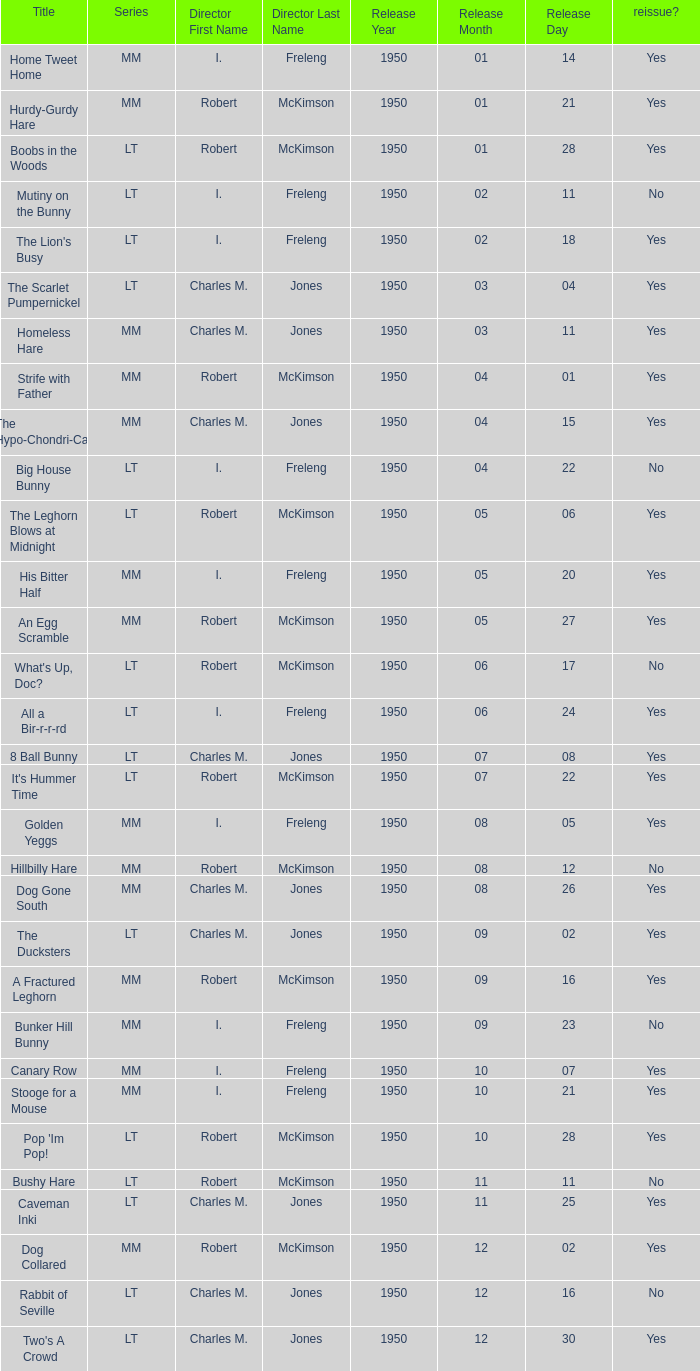Who directed An Egg Scramble? Robert McKimson. 